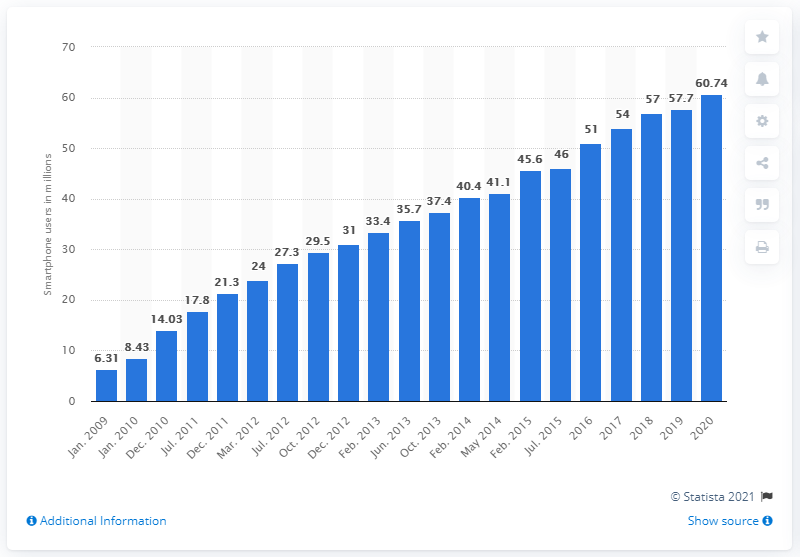Identify some key points in this picture. In 2020, there were approximately 60.74 million smartphone users in Germany. In 2009, there were 6.31 million smartphone users in Germany. 